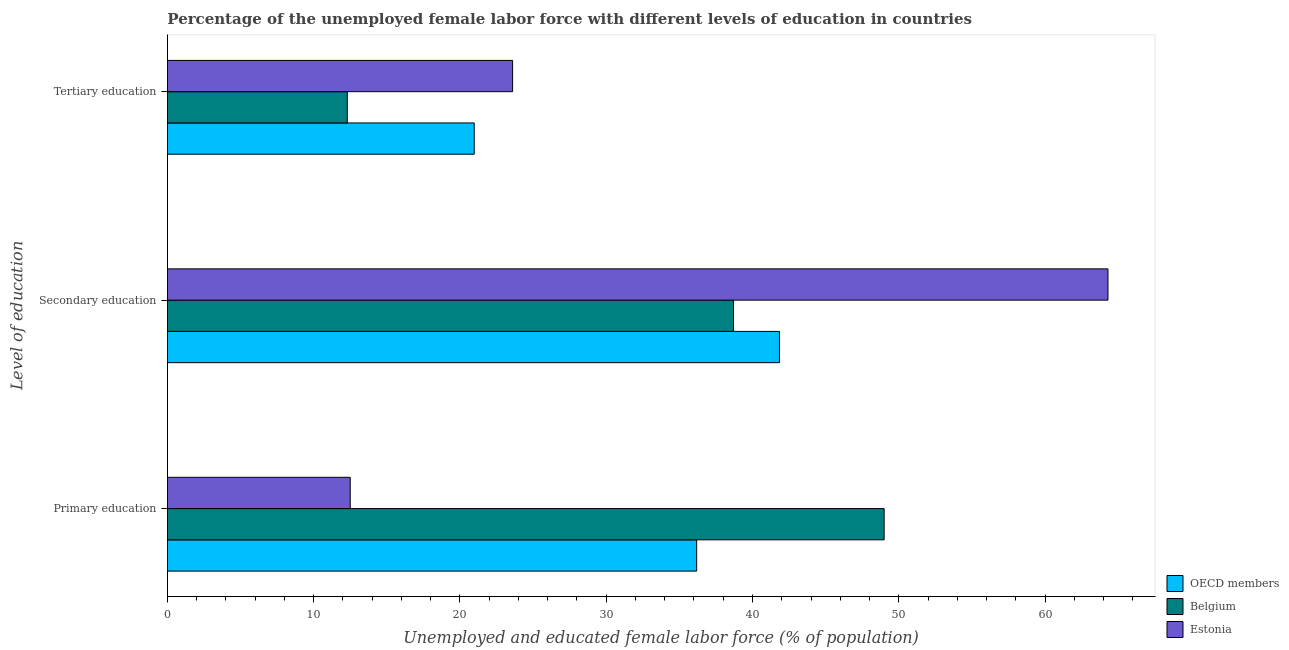Are the number of bars on each tick of the Y-axis equal?
Your response must be concise. Yes. How many bars are there on the 3rd tick from the top?
Your answer should be very brief. 3. What is the label of the 1st group of bars from the top?
Make the answer very short. Tertiary education. What is the percentage of female labor force who received primary education in OECD members?
Your answer should be compact. 36.18. Across all countries, what is the maximum percentage of female labor force who received primary education?
Your response must be concise. 49. In which country was the percentage of female labor force who received secondary education maximum?
Your answer should be very brief. Estonia. In which country was the percentage of female labor force who received tertiary education minimum?
Keep it short and to the point. Belgium. What is the total percentage of female labor force who received tertiary education in the graph?
Keep it short and to the point. 56.88. What is the difference between the percentage of female labor force who received tertiary education in Estonia and that in Belgium?
Your answer should be very brief. 11.3. What is the difference between the percentage of female labor force who received tertiary education in Estonia and the percentage of female labor force who received primary education in Belgium?
Your answer should be very brief. -25.4. What is the average percentage of female labor force who received primary education per country?
Your response must be concise. 32.56. What is the difference between the percentage of female labor force who received secondary education and percentage of female labor force who received primary education in Belgium?
Keep it short and to the point. -10.3. What is the ratio of the percentage of female labor force who received secondary education in Belgium to that in OECD members?
Offer a very short reply. 0.92. Is the percentage of female labor force who received secondary education in OECD members less than that in Belgium?
Your response must be concise. No. What is the difference between the highest and the second highest percentage of female labor force who received tertiary education?
Offer a very short reply. 2.62. What is the difference between the highest and the lowest percentage of female labor force who received primary education?
Provide a succinct answer. 36.5. In how many countries, is the percentage of female labor force who received secondary education greater than the average percentage of female labor force who received secondary education taken over all countries?
Your answer should be compact. 1. What does the 3rd bar from the top in Tertiary education represents?
Your answer should be compact. OECD members. Is it the case that in every country, the sum of the percentage of female labor force who received primary education and percentage of female labor force who received secondary education is greater than the percentage of female labor force who received tertiary education?
Ensure brevity in your answer.  Yes. Are all the bars in the graph horizontal?
Your answer should be very brief. Yes. Where does the legend appear in the graph?
Your response must be concise. Bottom right. How many legend labels are there?
Provide a succinct answer. 3. What is the title of the graph?
Ensure brevity in your answer.  Percentage of the unemployed female labor force with different levels of education in countries. What is the label or title of the X-axis?
Your response must be concise. Unemployed and educated female labor force (% of population). What is the label or title of the Y-axis?
Keep it short and to the point. Level of education. What is the Unemployed and educated female labor force (% of population) of OECD members in Primary education?
Offer a terse response. 36.18. What is the Unemployed and educated female labor force (% of population) in Belgium in Primary education?
Keep it short and to the point. 49. What is the Unemployed and educated female labor force (% of population) in Estonia in Primary education?
Offer a very short reply. 12.5. What is the Unemployed and educated female labor force (% of population) in OECD members in Secondary education?
Your answer should be very brief. 41.84. What is the Unemployed and educated female labor force (% of population) of Belgium in Secondary education?
Give a very brief answer. 38.7. What is the Unemployed and educated female labor force (% of population) in Estonia in Secondary education?
Your answer should be compact. 64.3. What is the Unemployed and educated female labor force (% of population) of OECD members in Tertiary education?
Give a very brief answer. 20.98. What is the Unemployed and educated female labor force (% of population) of Belgium in Tertiary education?
Give a very brief answer. 12.3. What is the Unemployed and educated female labor force (% of population) of Estonia in Tertiary education?
Provide a succinct answer. 23.6. Across all Level of education, what is the maximum Unemployed and educated female labor force (% of population) in OECD members?
Keep it short and to the point. 41.84. Across all Level of education, what is the maximum Unemployed and educated female labor force (% of population) in Estonia?
Provide a succinct answer. 64.3. Across all Level of education, what is the minimum Unemployed and educated female labor force (% of population) of OECD members?
Give a very brief answer. 20.98. Across all Level of education, what is the minimum Unemployed and educated female labor force (% of population) in Belgium?
Ensure brevity in your answer.  12.3. What is the total Unemployed and educated female labor force (% of population) in OECD members in the graph?
Make the answer very short. 99. What is the total Unemployed and educated female labor force (% of population) in Belgium in the graph?
Give a very brief answer. 100. What is the total Unemployed and educated female labor force (% of population) in Estonia in the graph?
Provide a short and direct response. 100.4. What is the difference between the Unemployed and educated female labor force (% of population) of OECD members in Primary education and that in Secondary education?
Ensure brevity in your answer.  -5.66. What is the difference between the Unemployed and educated female labor force (% of population) in Estonia in Primary education and that in Secondary education?
Ensure brevity in your answer.  -51.8. What is the difference between the Unemployed and educated female labor force (% of population) in OECD members in Primary education and that in Tertiary education?
Offer a terse response. 15.21. What is the difference between the Unemployed and educated female labor force (% of population) in Belgium in Primary education and that in Tertiary education?
Offer a terse response. 36.7. What is the difference between the Unemployed and educated female labor force (% of population) of OECD members in Secondary education and that in Tertiary education?
Provide a short and direct response. 20.87. What is the difference between the Unemployed and educated female labor force (% of population) in Belgium in Secondary education and that in Tertiary education?
Make the answer very short. 26.4. What is the difference between the Unemployed and educated female labor force (% of population) of Estonia in Secondary education and that in Tertiary education?
Keep it short and to the point. 40.7. What is the difference between the Unemployed and educated female labor force (% of population) of OECD members in Primary education and the Unemployed and educated female labor force (% of population) of Belgium in Secondary education?
Your answer should be very brief. -2.52. What is the difference between the Unemployed and educated female labor force (% of population) in OECD members in Primary education and the Unemployed and educated female labor force (% of population) in Estonia in Secondary education?
Your response must be concise. -28.12. What is the difference between the Unemployed and educated female labor force (% of population) of Belgium in Primary education and the Unemployed and educated female labor force (% of population) of Estonia in Secondary education?
Your answer should be very brief. -15.3. What is the difference between the Unemployed and educated female labor force (% of population) in OECD members in Primary education and the Unemployed and educated female labor force (% of population) in Belgium in Tertiary education?
Make the answer very short. 23.88. What is the difference between the Unemployed and educated female labor force (% of population) in OECD members in Primary education and the Unemployed and educated female labor force (% of population) in Estonia in Tertiary education?
Keep it short and to the point. 12.58. What is the difference between the Unemployed and educated female labor force (% of population) of Belgium in Primary education and the Unemployed and educated female labor force (% of population) of Estonia in Tertiary education?
Offer a very short reply. 25.4. What is the difference between the Unemployed and educated female labor force (% of population) of OECD members in Secondary education and the Unemployed and educated female labor force (% of population) of Belgium in Tertiary education?
Provide a succinct answer. 29.54. What is the difference between the Unemployed and educated female labor force (% of population) of OECD members in Secondary education and the Unemployed and educated female labor force (% of population) of Estonia in Tertiary education?
Keep it short and to the point. 18.24. What is the average Unemployed and educated female labor force (% of population) of OECD members per Level of education?
Your answer should be very brief. 33. What is the average Unemployed and educated female labor force (% of population) of Belgium per Level of education?
Give a very brief answer. 33.33. What is the average Unemployed and educated female labor force (% of population) in Estonia per Level of education?
Provide a succinct answer. 33.47. What is the difference between the Unemployed and educated female labor force (% of population) of OECD members and Unemployed and educated female labor force (% of population) of Belgium in Primary education?
Give a very brief answer. -12.82. What is the difference between the Unemployed and educated female labor force (% of population) in OECD members and Unemployed and educated female labor force (% of population) in Estonia in Primary education?
Ensure brevity in your answer.  23.68. What is the difference between the Unemployed and educated female labor force (% of population) in Belgium and Unemployed and educated female labor force (% of population) in Estonia in Primary education?
Your answer should be compact. 36.5. What is the difference between the Unemployed and educated female labor force (% of population) of OECD members and Unemployed and educated female labor force (% of population) of Belgium in Secondary education?
Offer a very short reply. 3.14. What is the difference between the Unemployed and educated female labor force (% of population) in OECD members and Unemployed and educated female labor force (% of population) in Estonia in Secondary education?
Offer a terse response. -22.46. What is the difference between the Unemployed and educated female labor force (% of population) in Belgium and Unemployed and educated female labor force (% of population) in Estonia in Secondary education?
Make the answer very short. -25.6. What is the difference between the Unemployed and educated female labor force (% of population) in OECD members and Unemployed and educated female labor force (% of population) in Belgium in Tertiary education?
Your answer should be compact. 8.68. What is the difference between the Unemployed and educated female labor force (% of population) in OECD members and Unemployed and educated female labor force (% of population) in Estonia in Tertiary education?
Ensure brevity in your answer.  -2.62. What is the ratio of the Unemployed and educated female labor force (% of population) of OECD members in Primary education to that in Secondary education?
Keep it short and to the point. 0.86. What is the ratio of the Unemployed and educated female labor force (% of population) of Belgium in Primary education to that in Secondary education?
Keep it short and to the point. 1.27. What is the ratio of the Unemployed and educated female labor force (% of population) of Estonia in Primary education to that in Secondary education?
Give a very brief answer. 0.19. What is the ratio of the Unemployed and educated female labor force (% of population) of OECD members in Primary education to that in Tertiary education?
Make the answer very short. 1.72. What is the ratio of the Unemployed and educated female labor force (% of population) in Belgium in Primary education to that in Tertiary education?
Give a very brief answer. 3.98. What is the ratio of the Unemployed and educated female labor force (% of population) of Estonia in Primary education to that in Tertiary education?
Provide a short and direct response. 0.53. What is the ratio of the Unemployed and educated female labor force (% of population) in OECD members in Secondary education to that in Tertiary education?
Keep it short and to the point. 1.99. What is the ratio of the Unemployed and educated female labor force (% of population) of Belgium in Secondary education to that in Tertiary education?
Ensure brevity in your answer.  3.15. What is the ratio of the Unemployed and educated female labor force (% of population) in Estonia in Secondary education to that in Tertiary education?
Your answer should be very brief. 2.72. What is the difference between the highest and the second highest Unemployed and educated female labor force (% of population) in OECD members?
Give a very brief answer. 5.66. What is the difference between the highest and the second highest Unemployed and educated female labor force (% of population) of Belgium?
Keep it short and to the point. 10.3. What is the difference between the highest and the second highest Unemployed and educated female labor force (% of population) in Estonia?
Make the answer very short. 40.7. What is the difference between the highest and the lowest Unemployed and educated female labor force (% of population) in OECD members?
Your answer should be very brief. 20.87. What is the difference between the highest and the lowest Unemployed and educated female labor force (% of population) of Belgium?
Ensure brevity in your answer.  36.7. What is the difference between the highest and the lowest Unemployed and educated female labor force (% of population) of Estonia?
Make the answer very short. 51.8. 